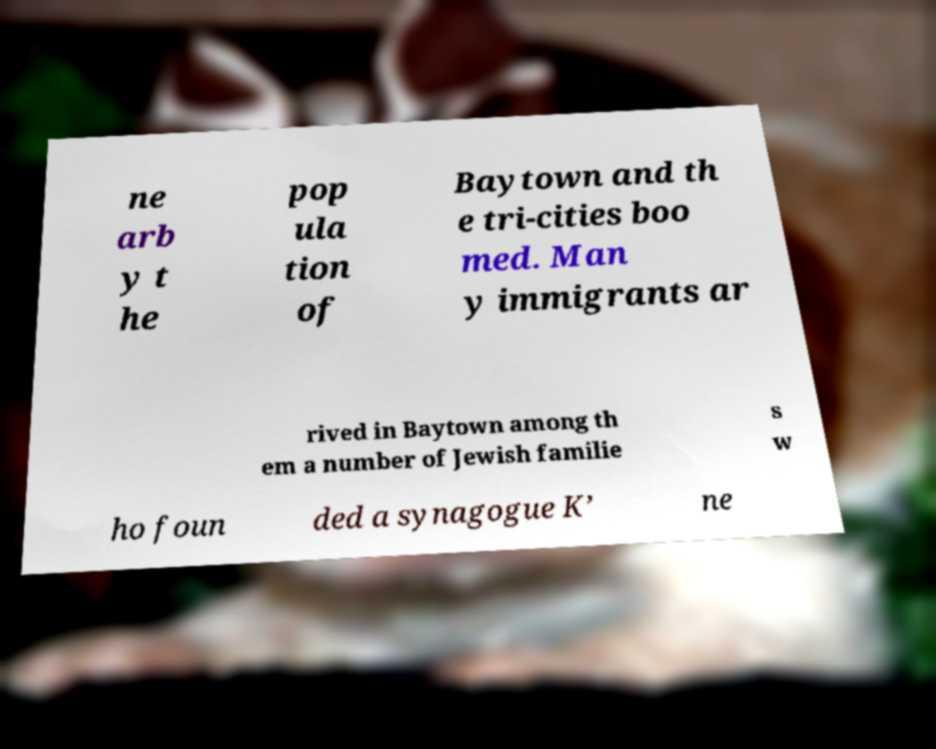Please read and relay the text visible in this image. What does it say? ne arb y t he pop ula tion of Baytown and th e tri-cities boo med. Man y immigrants ar rived in Baytown among th em a number of Jewish familie s w ho foun ded a synagogue K’ ne 